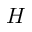Convert formula to latex. <formula><loc_0><loc_0><loc_500><loc_500>H</formula> 